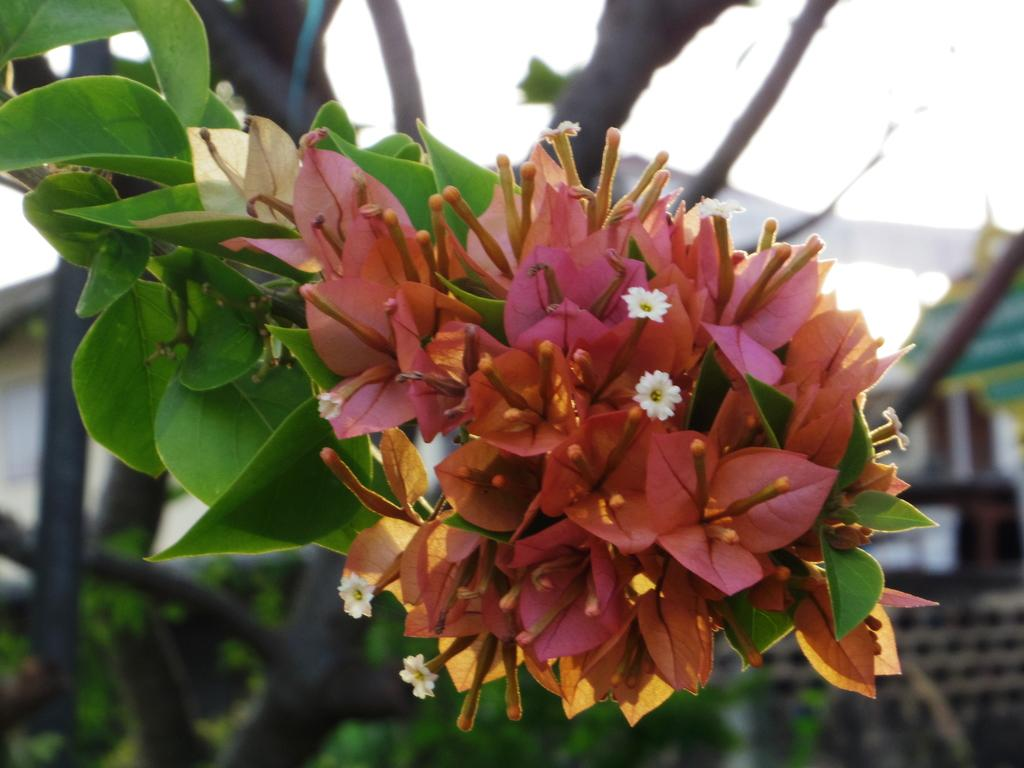What type of vegetation can be seen on the tree in the image? There are flowers on a tree in the image. What type of structure is visible in the image? There is a building visible in the image. What type of pleasure does the baby experience while playing with the reward in the image? There is no baby or reward present in the image. 